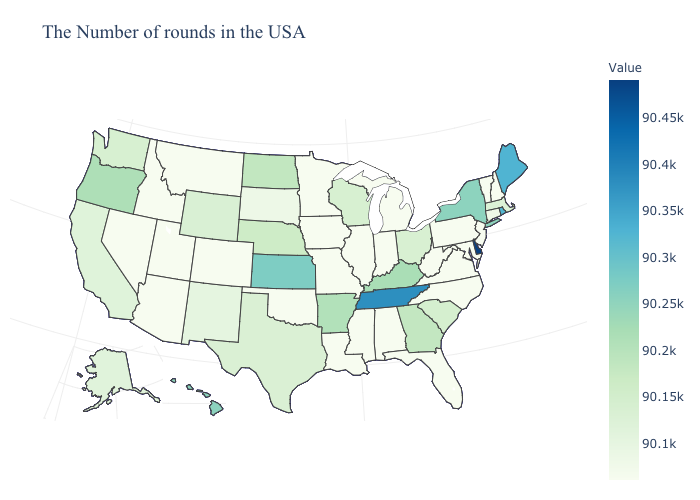Does Hawaii have the highest value in the West?
Give a very brief answer. Yes. Does Delaware have the highest value in the USA?
Write a very short answer. Yes. Is the legend a continuous bar?
Keep it brief. Yes. Does Maryland have the lowest value in the South?
Write a very short answer. Yes. Does Nebraska have the highest value in the MidWest?
Be succinct. No. Is the legend a continuous bar?
Be succinct. Yes. 